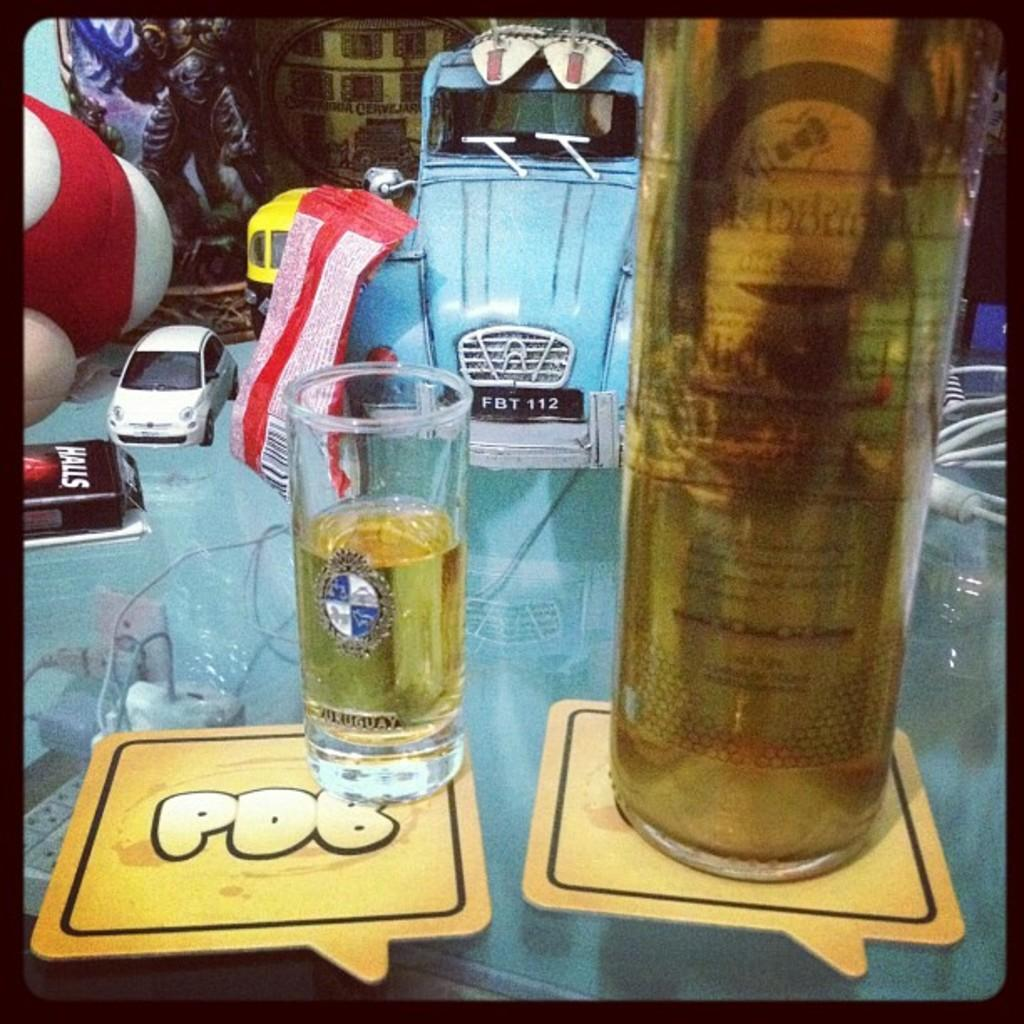<image>
Share a concise interpretation of the image provided. A table full or random items has a PDB coaster on it with a shot on top. 